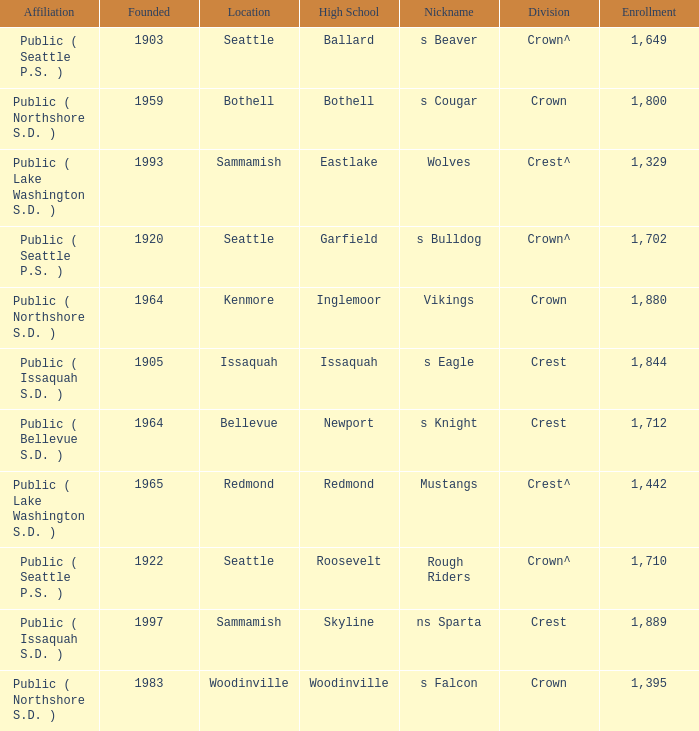What High School with a nickname of S Eagle has a Division of crest? Issaquah. 